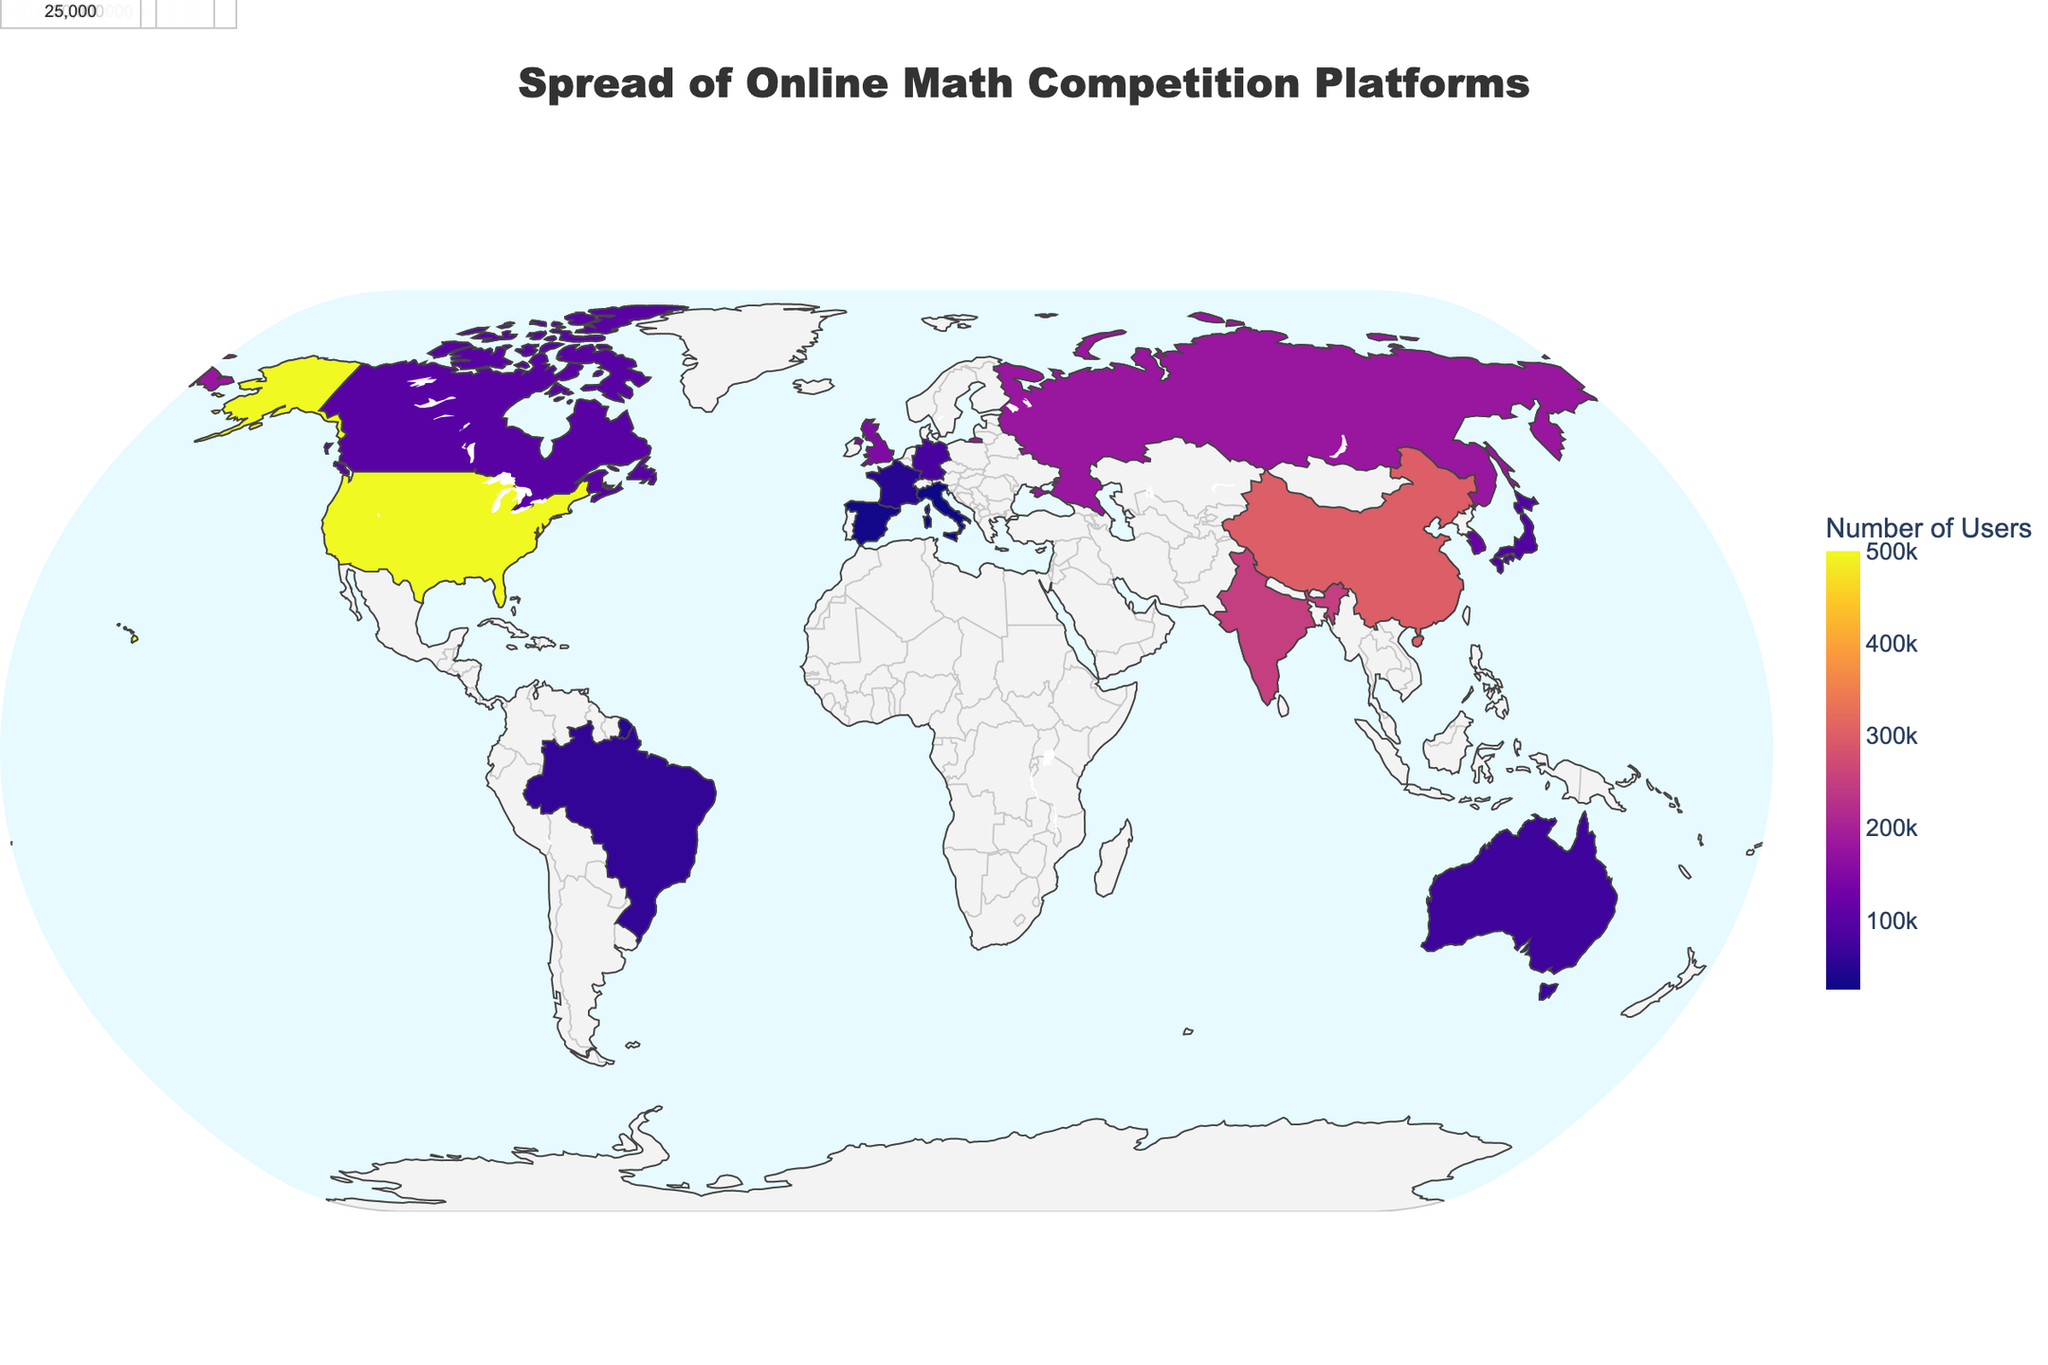What's the title of the plot? The title is usually located at the top of the plot within a title box. In this plot, the title is "Spread of Online Math Competition Platforms".
Answer: "Spread of Online Math Competition Platforms" How many regions are represented in the plot? Count the number of unique regions listed in the plot. By checking, we can see there are 15 regions.
Answer: 15 Which platform has the highest number of users? We look at the data points and compare the "Users" field to find the highest value, which corresponds to "Art of Problem Solving" with 500,000 users.
Answer: Art of Problem Solving What is the combined user base of Brilliant from both China and India? The number of users in China is 300,000 and in India is 250,000. Adding these two values together, we get 550,000.
Answer: 550,000 Which region has the least number of users, and how many users does it have? Looking for the smallest number in the "Users" column, we find that "Kangourou Italia" in Italy has 25,000 users.
Answer: Italy, 25,000 What is the difference in user base between Codeforces in Russia and UKMT in the United Kingdom? Subtract the users of UKMT (150,000) from Codeforces (180,000). The difference is 30,000 users.
Answer: 30,000 Which region in Asia has the largest user base for math competition platforms? By looking at all the regions in Asia, South Korea has "Math Olympiad Prep" with 120,000 users which is the highest within Asia.
Answer: South Korea What's the average number of users across all platforms shown on the plot? Add all the user counts (500,000 + 300,000 + 250,000 + 180,000 + 150,000 + 120,000 + 100,000 + 90,000 + 80,000 + 70,000 + 60,000 + 50,000 + 40,000 + 30,000 + 25,000). The total is 2,045,000. Dividing by the number of regions (15), the average is 136,333.33.
Answer: 136,333.33 Compare the user bases of platforms in North America and Europe. Which continent has more users? Summing up the users in North America (United States and Canada: 500,000 + 100,000 = 600,000) and Europe (Russia, United Kingdom, Germany, France, Spain, Italy; 180,000 + 150,000 + 80,000 + 50,000 + 30,000 + 25,000 = 515,000). North America has more users.
Answer: North America What percentage of the total user base does the "Art of Problem Solving" platform in the United States represent? The total user base is 2,045,000. The Art of Problem Solving has 500,000 users. The percentage is (500,000 / 2,045,000) * 100%, which is approximately 24.44%.
Answer: 24.44% 